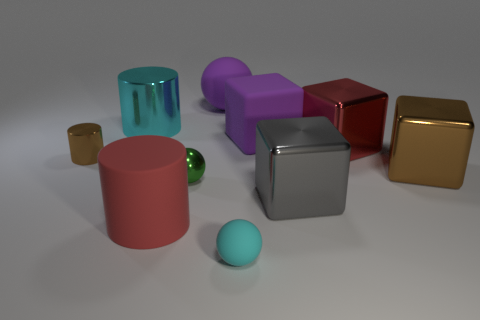What can you infer about the textures of the different objects? From the image, we can infer that there's a variety of textures. The small brown cube and the golden cube seem to have matte surfaces, while the metallic cube has a reflective texture. The cylinders and the small green sphere appear to have a smoother, glossier finish. 